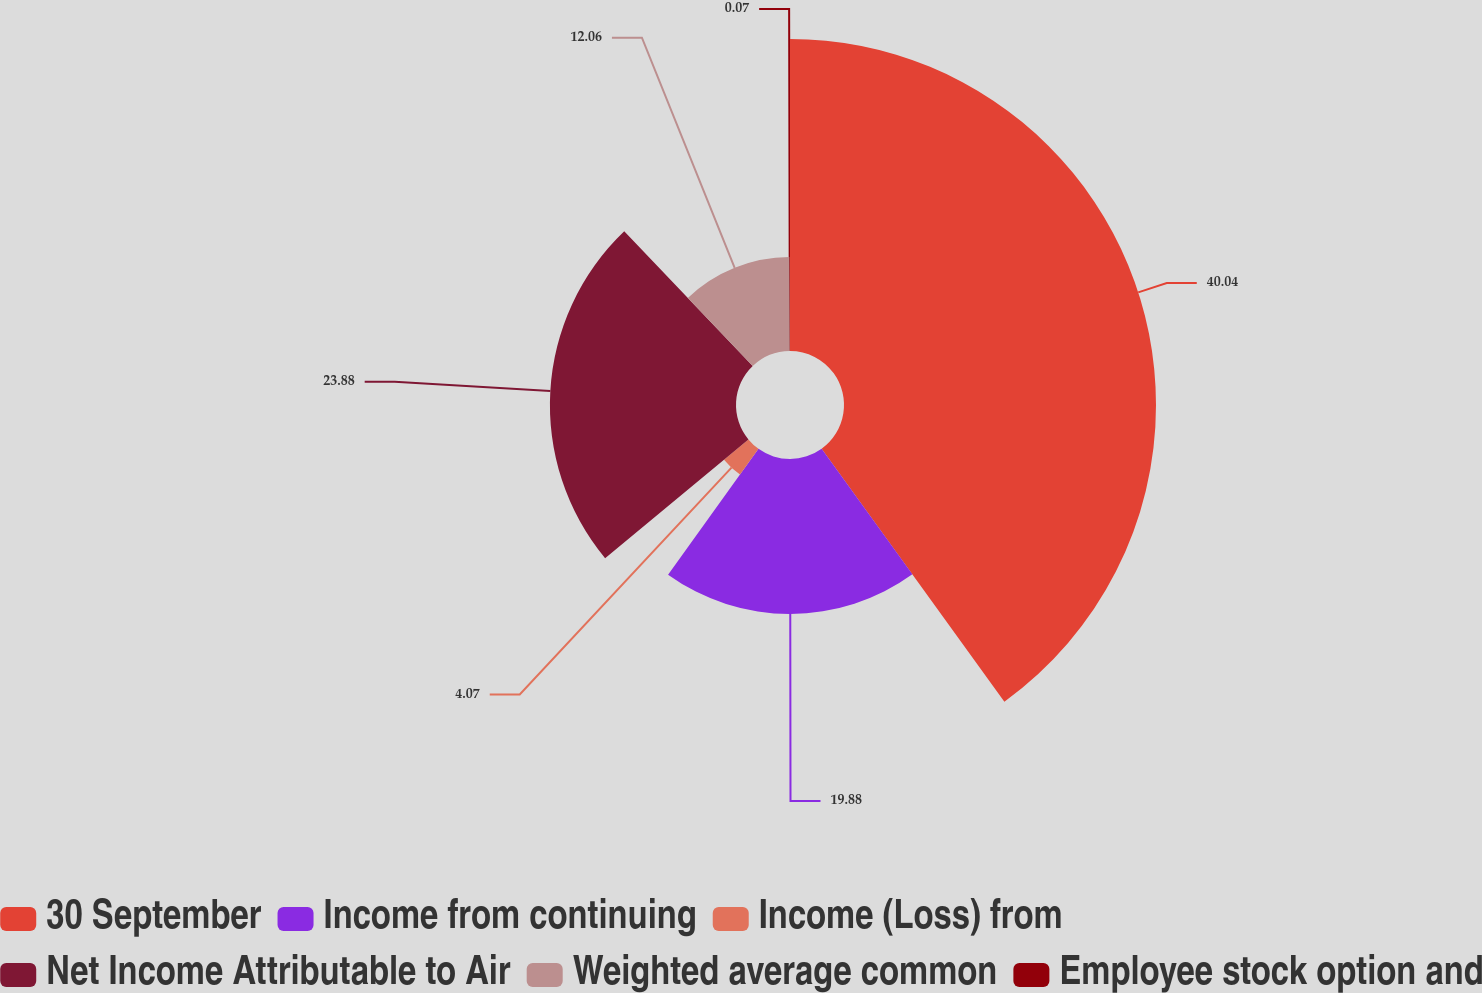Convert chart to OTSL. <chart><loc_0><loc_0><loc_500><loc_500><pie_chart><fcel>30 September<fcel>Income from continuing<fcel>Income (Loss) from<fcel>Net Income Attributable to Air<fcel>Weighted average common<fcel>Employee stock option and<nl><fcel>40.04%<fcel>19.88%<fcel>4.07%<fcel>23.88%<fcel>12.06%<fcel>0.07%<nl></chart> 